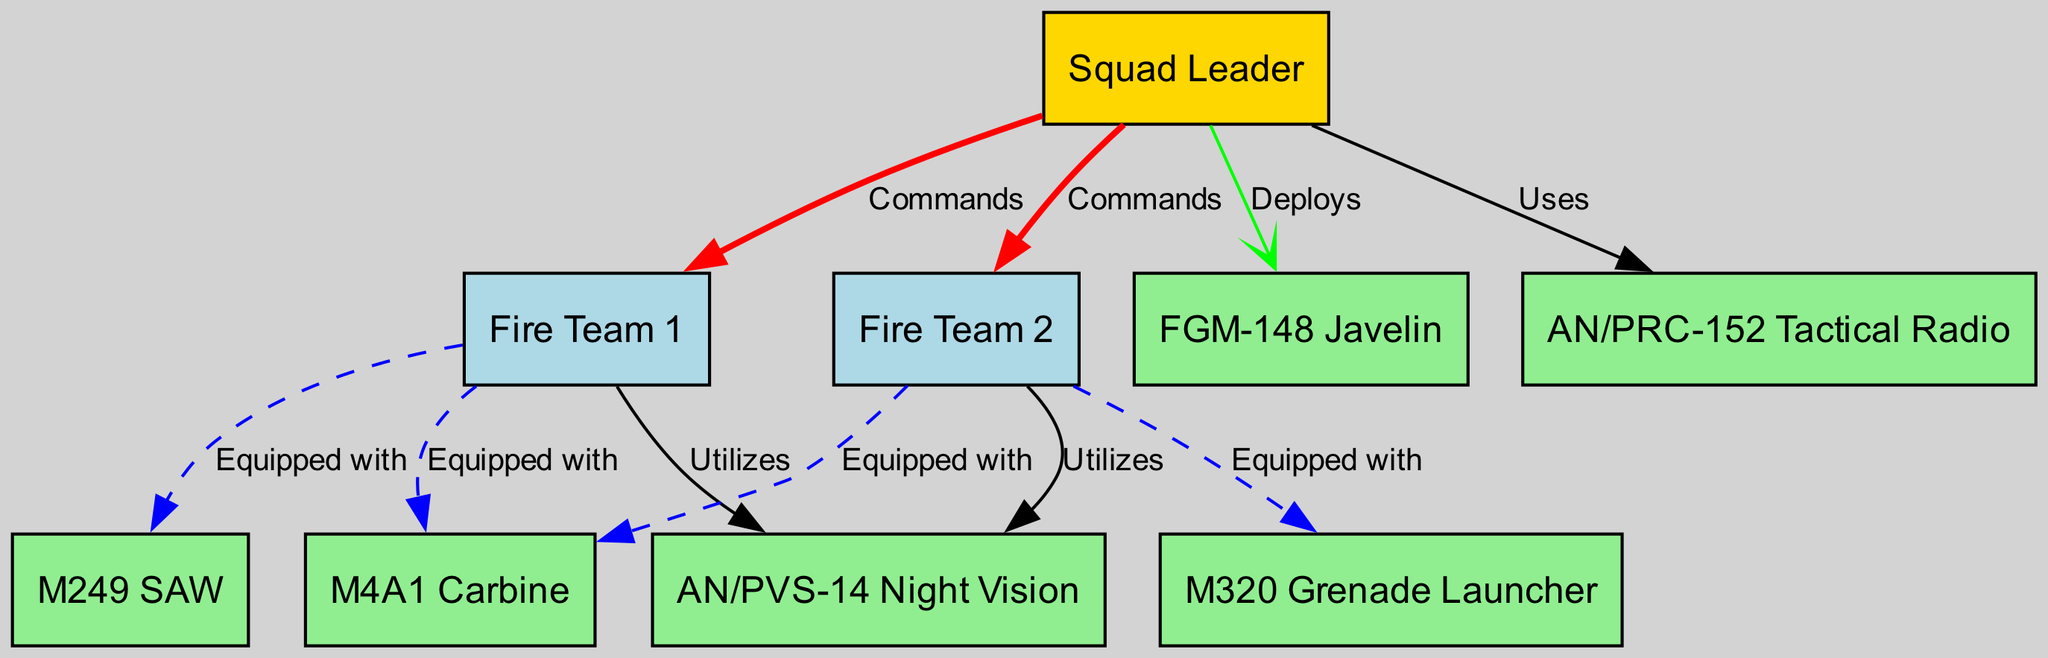What is the role of the squad leader? The squad leader is depicted at the top of the diagram and is labeled "Squad Leader," indicating their role. They are responsible for commanding two fire teams and deploying weapons.
Answer: Squad Leader How many fire teams are shown in the diagram? The diagram has two nodes labeled "Fire Team 1" and "Fire Team 2," clearly indicating the presence of two fire teams.
Answer: 2 Which weapon is equipped by both fire teams? The diagram shows an edge labeled "Equipped with" connecting both fire teams to a weapon node labeled "M4A1 Carbine." This indicates that the M4A1 Carbine is common to both fire teams.
Answer: M4A1 Carbine What does the squad leader deploy? The diagram shows a directed edge labeled "Deploys" from the squad leader node to the weapon node labeled "FGM-148 Javelin," indicating that this is a weapon deployed by the squad leader.
Answer: FGM-148 Javelin Which component is utilized by both fire teams? The diagram features edges labeled "Utilizes" from both fire team nodes to the equipment node labeled "AN/PVS-14 Night Vision," indicating that both fire teams use this piece of equipment.
Answer: AN/PVS-14 Night Vision What is the connection type between fire team 1 and the M249? In the diagram, there is a dashed edge labeled "Equipped with" connecting "Fire Team 1" to "M249 SAW," which indicates that this is the nature of this connection.
Answer: Equipped with How does the squad leader communicate? The diagram includes an edge labeled "Uses" that connects the squad leader to the node labeled "AN/PRC-152 Tactical Radio," showing how communication is facilitated.
Answer: AN/PRC-152 Tactical Radio Which two weapons does Fire Team 1 have? The diagram shows "Fire Team 1" connected by dashed edges labeled "Equipped with" to both "M4A1 Carbine" and "M249 SAW," identifying the two weapons that fire team 1 carries.
Answer: M4A1 Carbine, M249 SAW What is the relationship between the squad leader and the fire teams? The diagram depicts the relations as "Commands" with directed edges from the "Squad Leader" to both "Fire Team 1" and "Fire Team 2," establishing the command structure.
Answer: Commands 